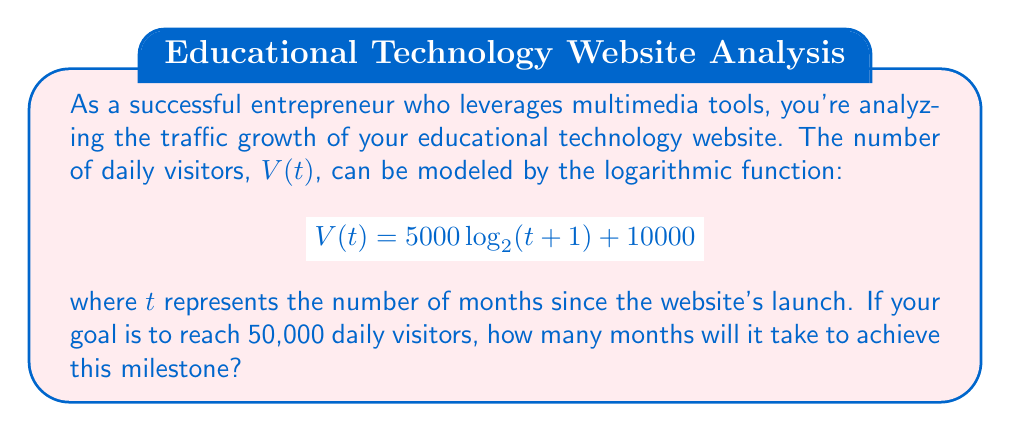What is the answer to this math problem? Let's approach this step-by-step:

1) We need to solve the equation:
   $$50000 = 5000 \log_2(t+1) + 10000$$

2) First, subtract 10000 from both sides:
   $$40000 = 5000 \log_2(t+1)$$

3) Divide both sides by 5000:
   $$8 = \log_2(t+1)$$

4) To solve for $t$, we need to apply the inverse function of $\log_2$, which is $2^x$:
   $$2^8 = t+1$$

5) Simplify the left side:
   $$256 = t+1$$

6) Subtract 1 from both sides to isolate $t$:
   $$255 = t$$

Therefore, it will take 255 months to reach 50,000 daily visitors.

To verify:
$$V(255) = 5000 \log_2(255+1) + 10000$$
$$= 5000 \log_2(256) + 10000$$
$$= 5000 \cdot 8 + 10000 = 50000$$

This analysis demonstrates how logarithmic functions can model gradual growth patterns in website traffic, which is crucial for long-term business planning in the digital education space.
Answer: It will take 255 months (approximately 21 years and 3 months) to reach 50,000 daily visitors. 